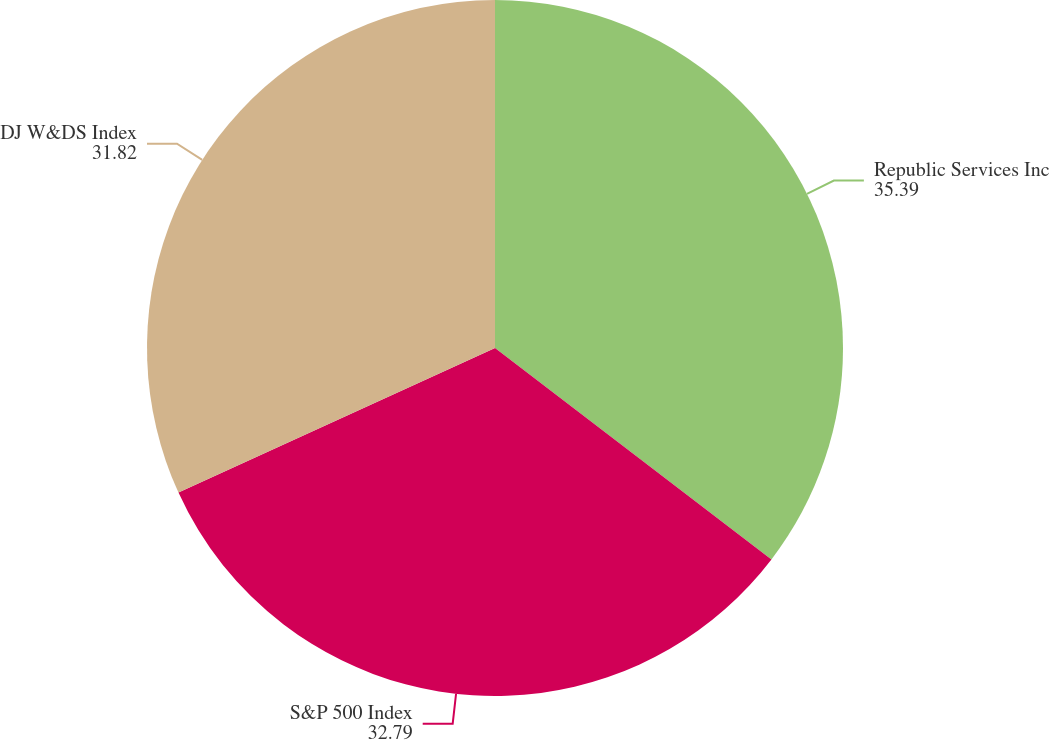Convert chart. <chart><loc_0><loc_0><loc_500><loc_500><pie_chart><fcel>Republic Services Inc<fcel>S&P 500 Index<fcel>DJ W&DS Index<nl><fcel>35.39%<fcel>32.79%<fcel>31.82%<nl></chart> 